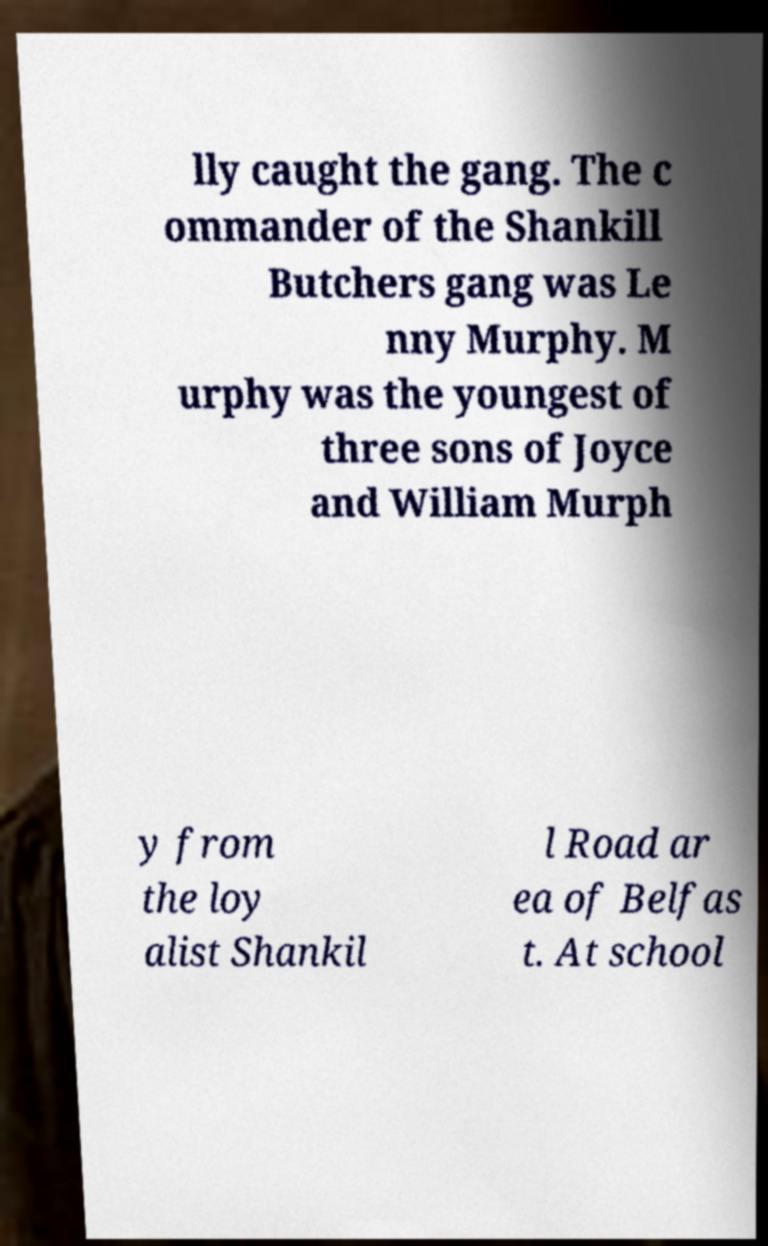I need the written content from this picture converted into text. Can you do that? lly caught the gang. The c ommander of the Shankill Butchers gang was Le nny Murphy. M urphy was the youngest of three sons of Joyce and William Murph y from the loy alist Shankil l Road ar ea of Belfas t. At school 